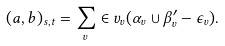<formula> <loc_0><loc_0><loc_500><loc_500>( a , b ) _ { s , t } = \sum _ { v } \in v _ { v } ( \alpha _ { v } \cup \beta ^ { \prime } _ { v } - \epsilon _ { v } ) .</formula> 